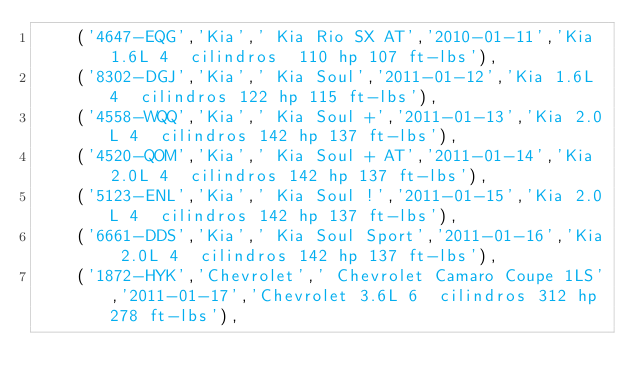Convert code to text. <code><loc_0><loc_0><loc_500><loc_500><_SQL_>    ('4647-EQG','Kia',' Kia Rio SX AT','2010-01-11','Kia 1.6L 4  cilindros  110 hp 107 ft-lbs'),
    ('8302-DGJ','Kia',' Kia Soul','2011-01-12','Kia 1.6L 4  cilindros 122 hp 115 ft-lbs'),
    ('4558-WQQ','Kia',' Kia Soul +','2011-01-13','Kia 2.0L 4  cilindros 142 hp 137 ft-lbs'),
    ('4520-QOM','Kia',' Kia Soul + AT','2011-01-14','Kia 2.0L 4  cilindros 142 hp 137 ft-lbs'),
    ('5123-ENL','Kia',' Kia Soul !','2011-01-15','Kia 2.0L 4  cilindros 142 hp 137 ft-lbs'),
    ('6661-DDS','Kia',' Kia Soul Sport','2011-01-16','Kia 2.0L 4  cilindros 142 hp 137 ft-lbs'),
    ('1872-HYK','Chevrolet',' Chevrolet Camaro Coupe 1LS','2011-01-17','Chevrolet 3.6L 6  cilindros 312 hp 278 ft-lbs'),</code> 